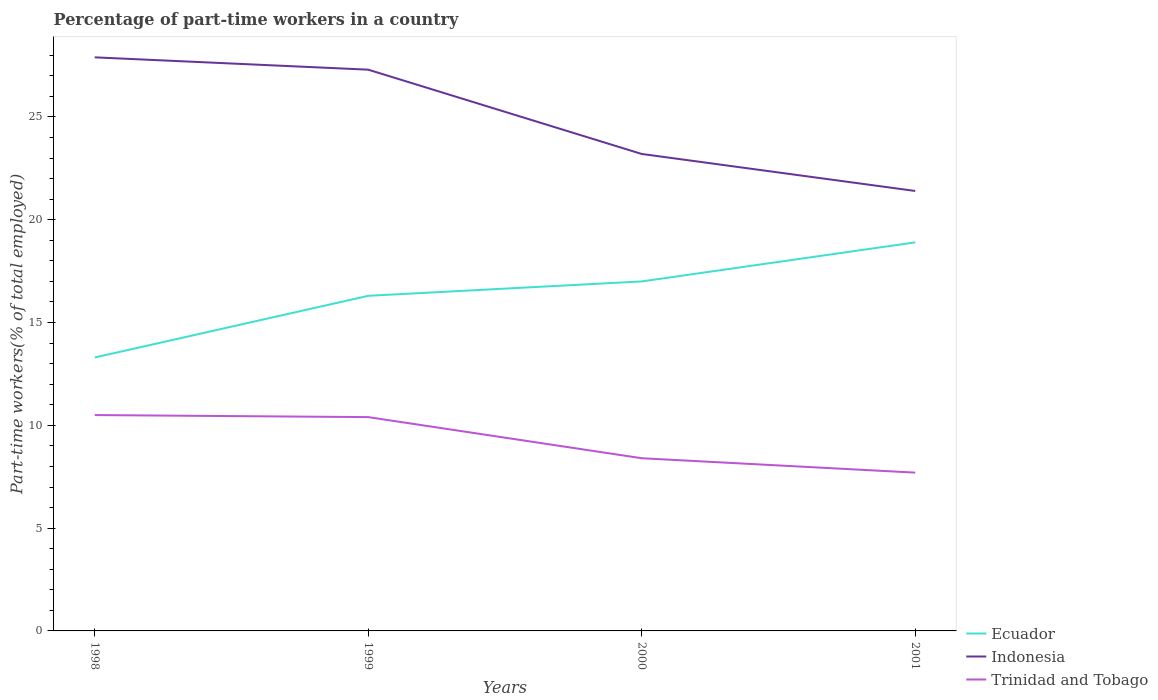Does the line corresponding to Ecuador intersect with the line corresponding to Trinidad and Tobago?
Make the answer very short. No. Across all years, what is the maximum percentage of part-time workers in Ecuador?
Make the answer very short. 13.3. What is the total percentage of part-time workers in Indonesia in the graph?
Keep it short and to the point. 4.7. What is the difference between the highest and the second highest percentage of part-time workers in Trinidad and Tobago?
Provide a succinct answer. 2.8. What is the difference between the highest and the lowest percentage of part-time workers in Indonesia?
Ensure brevity in your answer.  2. Is the percentage of part-time workers in Trinidad and Tobago strictly greater than the percentage of part-time workers in Indonesia over the years?
Give a very brief answer. Yes. What is the difference between two consecutive major ticks on the Y-axis?
Provide a succinct answer. 5. Are the values on the major ticks of Y-axis written in scientific E-notation?
Keep it short and to the point. No. Does the graph contain any zero values?
Offer a very short reply. No. Where does the legend appear in the graph?
Keep it short and to the point. Bottom right. How many legend labels are there?
Offer a very short reply. 3. How are the legend labels stacked?
Provide a short and direct response. Vertical. What is the title of the graph?
Make the answer very short. Percentage of part-time workers in a country. What is the label or title of the Y-axis?
Give a very brief answer. Part-time workers(% of total employed). What is the Part-time workers(% of total employed) in Ecuador in 1998?
Make the answer very short. 13.3. What is the Part-time workers(% of total employed) in Indonesia in 1998?
Your answer should be compact. 27.9. What is the Part-time workers(% of total employed) of Ecuador in 1999?
Your answer should be compact. 16.3. What is the Part-time workers(% of total employed) of Indonesia in 1999?
Provide a succinct answer. 27.3. What is the Part-time workers(% of total employed) in Trinidad and Tobago in 1999?
Offer a very short reply. 10.4. What is the Part-time workers(% of total employed) in Ecuador in 2000?
Offer a very short reply. 17. What is the Part-time workers(% of total employed) of Indonesia in 2000?
Offer a very short reply. 23.2. What is the Part-time workers(% of total employed) in Trinidad and Tobago in 2000?
Offer a very short reply. 8.4. What is the Part-time workers(% of total employed) in Ecuador in 2001?
Provide a short and direct response. 18.9. What is the Part-time workers(% of total employed) of Indonesia in 2001?
Keep it short and to the point. 21.4. What is the Part-time workers(% of total employed) of Trinidad and Tobago in 2001?
Provide a succinct answer. 7.7. Across all years, what is the maximum Part-time workers(% of total employed) in Ecuador?
Your answer should be very brief. 18.9. Across all years, what is the maximum Part-time workers(% of total employed) in Indonesia?
Make the answer very short. 27.9. Across all years, what is the minimum Part-time workers(% of total employed) in Ecuador?
Make the answer very short. 13.3. Across all years, what is the minimum Part-time workers(% of total employed) in Indonesia?
Keep it short and to the point. 21.4. Across all years, what is the minimum Part-time workers(% of total employed) in Trinidad and Tobago?
Offer a terse response. 7.7. What is the total Part-time workers(% of total employed) in Ecuador in the graph?
Your response must be concise. 65.5. What is the total Part-time workers(% of total employed) in Indonesia in the graph?
Make the answer very short. 99.8. What is the total Part-time workers(% of total employed) in Trinidad and Tobago in the graph?
Your response must be concise. 37. What is the difference between the Part-time workers(% of total employed) in Indonesia in 1998 and that in 1999?
Make the answer very short. 0.6. What is the difference between the Part-time workers(% of total employed) in Trinidad and Tobago in 1998 and that in 2000?
Ensure brevity in your answer.  2.1. What is the difference between the Part-time workers(% of total employed) of Indonesia in 1998 and that in 2001?
Offer a very short reply. 6.5. What is the difference between the Part-time workers(% of total employed) of Ecuador in 1999 and that in 2000?
Your answer should be very brief. -0.7. What is the difference between the Part-time workers(% of total employed) in Trinidad and Tobago in 1999 and that in 2000?
Give a very brief answer. 2. What is the difference between the Part-time workers(% of total employed) of Ecuador in 2000 and that in 2001?
Your answer should be compact. -1.9. What is the difference between the Part-time workers(% of total employed) of Indonesia in 2000 and that in 2001?
Provide a short and direct response. 1.8. What is the difference between the Part-time workers(% of total employed) in Ecuador in 1998 and the Part-time workers(% of total employed) in Trinidad and Tobago in 2000?
Offer a very short reply. 4.9. What is the difference between the Part-time workers(% of total employed) of Indonesia in 1998 and the Part-time workers(% of total employed) of Trinidad and Tobago in 2000?
Your answer should be very brief. 19.5. What is the difference between the Part-time workers(% of total employed) of Ecuador in 1998 and the Part-time workers(% of total employed) of Indonesia in 2001?
Provide a short and direct response. -8.1. What is the difference between the Part-time workers(% of total employed) in Indonesia in 1998 and the Part-time workers(% of total employed) in Trinidad and Tobago in 2001?
Your response must be concise. 20.2. What is the difference between the Part-time workers(% of total employed) of Ecuador in 1999 and the Part-time workers(% of total employed) of Indonesia in 2000?
Keep it short and to the point. -6.9. What is the difference between the Part-time workers(% of total employed) in Ecuador in 1999 and the Part-time workers(% of total employed) in Trinidad and Tobago in 2000?
Provide a succinct answer. 7.9. What is the difference between the Part-time workers(% of total employed) in Ecuador in 1999 and the Part-time workers(% of total employed) in Indonesia in 2001?
Your answer should be very brief. -5.1. What is the difference between the Part-time workers(% of total employed) of Indonesia in 1999 and the Part-time workers(% of total employed) of Trinidad and Tobago in 2001?
Make the answer very short. 19.6. What is the difference between the Part-time workers(% of total employed) in Ecuador in 2000 and the Part-time workers(% of total employed) in Indonesia in 2001?
Make the answer very short. -4.4. What is the difference between the Part-time workers(% of total employed) in Ecuador in 2000 and the Part-time workers(% of total employed) in Trinidad and Tobago in 2001?
Provide a succinct answer. 9.3. What is the difference between the Part-time workers(% of total employed) in Indonesia in 2000 and the Part-time workers(% of total employed) in Trinidad and Tobago in 2001?
Your response must be concise. 15.5. What is the average Part-time workers(% of total employed) in Ecuador per year?
Your answer should be compact. 16.38. What is the average Part-time workers(% of total employed) in Indonesia per year?
Offer a terse response. 24.95. What is the average Part-time workers(% of total employed) in Trinidad and Tobago per year?
Your answer should be compact. 9.25. In the year 1998, what is the difference between the Part-time workers(% of total employed) of Ecuador and Part-time workers(% of total employed) of Indonesia?
Offer a very short reply. -14.6. In the year 1998, what is the difference between the Part-time workers(% of total employed) in Ecuador and Part-time workers(% of total employed) in Trinidad and Tobago?
Your response must be concise. 2.8. In the year 1998, what is the difference between the Part-time workers(% of total employed) of Indonesia and Part-time workers(% of total employed) of Trinidad and Tobago?
Provide a short and direct response. 17.4. In the year 1999, what is the difference between the Part-time workers(% of total employed) in Ecuador and Part-time workers(% of total employed) in Trinidad and Tobago?
Offer a very short reply. 5.9. In the year 2000, what is the difference between the Part-time workers(% of total employed) in Ecuador and Part-time workers(% of total employed) in Indonesia?
Make the answer very short. -6.2. In the year 2000, what is the difference between the Part-time workers(% of total employed) in Ecuador and Part-time workers(% of total employed) in Trinidad and Tobago?
Provide a short and direct response. 8.6. In the year 2001, what is the difference between the Part-time workers(% of total employed) of Ecuador and Part-time workers(% of total employed) of Indonesia?
Make the answer very short. -2.5. In the year 2001, what is the difference between the Part-time workers(% of total employed) of Indonesia and Part-time workers(% of total employed) of Trinidad and Tobago?
Offer a terse response. 13.7. What is the ratio of the Part-time workers(% of total employed) in Ecuador in 1998 to that in 1999?
Ensure brevity in your answer.  0.82. What is the ratio of the Part-time workers(% of total employed) in Indonesia in 1998 to that in 1999?
Your answer should be very brief. 1.02. What is the ratio of the Part-time workers(% of total employed) in Trinidad and Tobago in 1998 to that in 1999?
Your answer should be compact. 1.01. What is the ratio of the Part-time workers(% of total employed) of Ecuador in 1998 to that in 2000?
Provide a short and direct response. 0.78. What is the ratio of the Part-time workers(% of total employed) of Indonesia in 1998 to that in 2000?
Provide a short and direct response. 1.2. What is the ratio of the Part-time workers(% of total employed) in Trinidad and Tobago in 1998 to that in 2000?
Provide a succinct answer. 1.25. What is the ratio of the Part-time workers(% of total employed) in Ecuador in 1998 to that in 2001?
Give a very brief answer. 0.7. What is the ratio of the Part-time workers(% of total employed) of Indonesia in 1998 to that in 2001?
Your answer should be very brief. 1.3. What is the ratio of the Part-time workers(% of total employed) in Trinidad and Tobago in 1998 to that in 2001?
Your response must be concise. 1.36. What is the ratio of the Part-time workers(% of total employed) of Ecuador in 1999 to that in 2000?
Your answer should be compact. 0.96. What is the ratio of the Part-time workers(% of total employed) of Indonesia in 1999 to that in 2000?
Offer a very short reply. 1.18. What is the ratio of the Part-time workers(% of total employed) in Trinidad and Tobago in 1999 to that in 2000?
Your response must be concise. 1.24. What is the ratio of the Part-time workers(% of total employed) of Ecuador in 1999 to that in 2001?
Your response must be concise. 0.86. What is the ratio of the Part-time workers(% of total employed) in Indonesia in 1999 to that in 2001?
Your answer should be very brief. 1.28. What is the ratio of the Part-time workers(% of total employed) in Trinidad and Tobago in 1999 to that in 2001?
Your answer should be compact. 1.35. What is the ratio of the Part-time workers(% of total employed) of Ecuador in 2000 to that in 2001?
Your response must be concise. 0.9. What is the ratio of the Part-time workers(% of total employed) of Indonesia in 2000 to that in 2001?
Ensure brevity in your answer.  1.08. What is the difference between the highest and the second highest Part-time workers(% of total employed) of Ecuador?
Your answer should be very brief. 1.9. What is the difference between the highest and the second highest Part-time workers(% of total employed) in Indonesia?
Ensure brevity in your answer.  0.6. What is the difference between the highest and the second highest Part-time workers(% of total employed) of Trinidad and Tobago?
Make the answer very short. 0.1. What is the difference between the highest and the lowest Part-time workers(% of total employed) of Ecuador?
Ensure brevity in your answer.  5.6. What is the difference between the highest and the lowest Part-time workers(% of total employed) in Indonesia?
Your response must be concise. 6.5. 